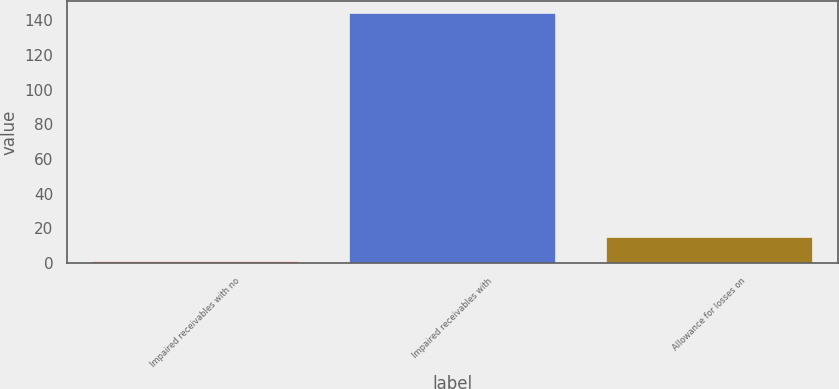Convert chart to OTSL. <chart><loc_0><loc_0><loc_500><loc_500><bar_chart><fcel>Impaired receivables with no<fcel>Impaired receivables with<fcel>Allowance for losses on<nl><fcel>1<fcel>144<fcel>15.3<nl></chart> 